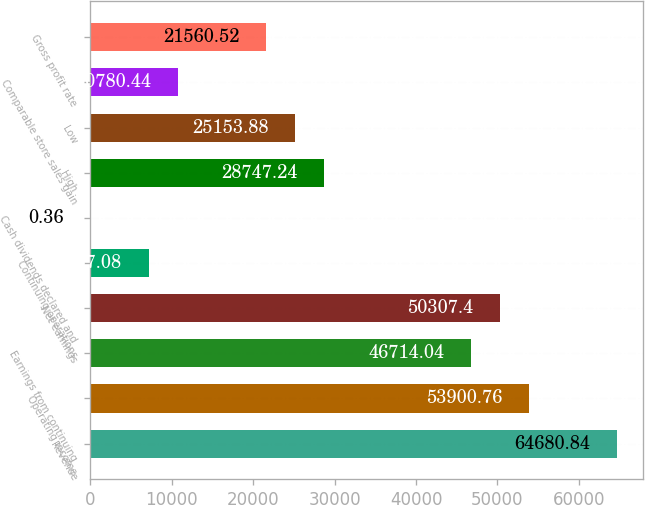Convert chart. <chart><loc_0><loc_0><loc_500><loc_500><bar_chart><fcel>Revenue<fcel>Operating income<fcel>Earnings from continuing<fcel>Net earnings<fcel>Continuing operations<fcel>Cash dividends declared and<fcel>High<fcel>Low<fcel>Comparable store sales gain<fcel>Gross profit rate<nl><fcel>64680.8<fcel>53900.8<fcel>46714<fcel>50307.4<fcel>7187.08<fcel>0.36<fcel>28747.2<fcel>25153.9<fcel>10780.4<fcel>21560.5<nl></chart> 